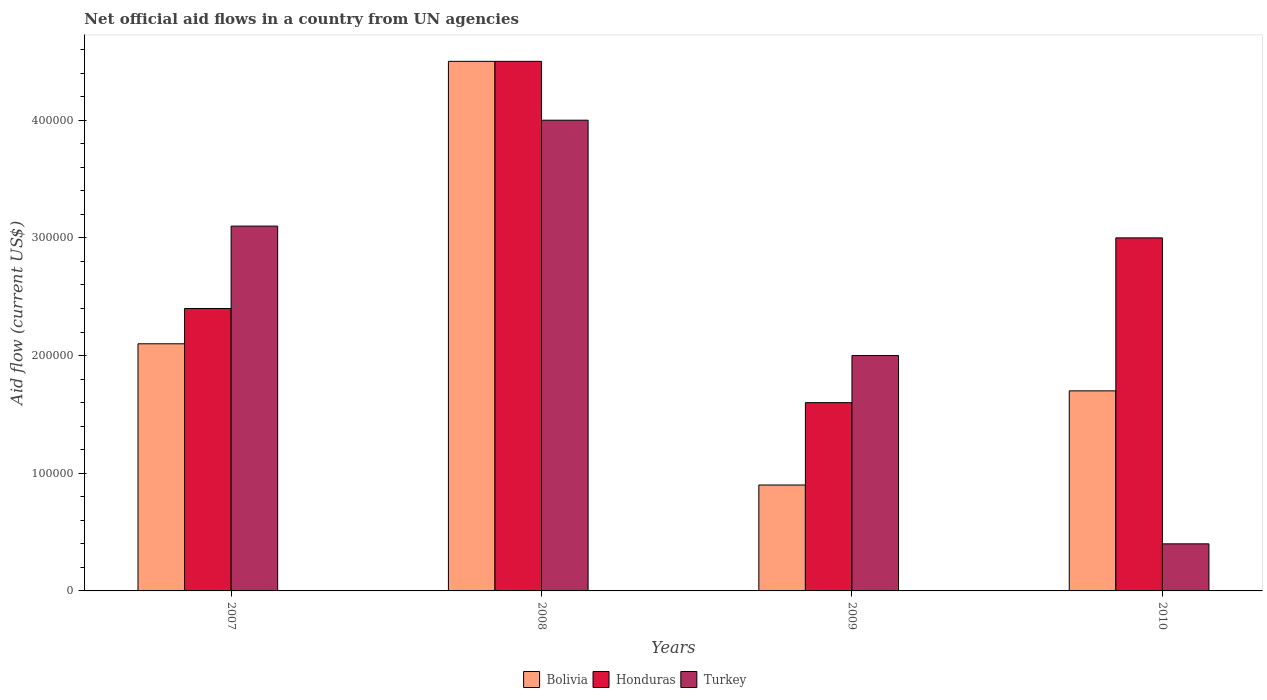How many different coloured bars are there?
Give a very brief answer. 3. How many groups of bars are there?
Offer a very short reply. 4. How many bars are there on the 4th tick from the right?
Provide a short and direct response. 3. What is the label of the 1st group of bars from the left?
Provide a short and direct response. 2007. Across all years, what is the maximum net official aid flow in Turkey?
Give a very brief answer. 4.00e+05. Across all years, what is the minimum net official aid flow in Turkey?
Your answer should be very brief. 4.00e+04. In which year was the net official aid flow in Honduras minimum?
Make the answer very short. 2009. What is the total net official aid flow in Bolivia in the graph?
Provide a short and direct response. 9.20e+05. What is the difference between the net official aid flow in Turkey in 2008 and that in 2009?
Your answer should be compact. 2.00e+05. What is the difference between the net official aid flow in Honduras in 2010 and the net official aid flow in Turkey in 2009?
Provide a short and direct response. 1.00e+05. What is the average net official aid flow in Honduras per year?
Provide a short and direct response. 2.88e+05. What is the ratio of the net official aid flow in Turkey in 2007 to that in 2008?
Offer a very short reply. 0.78. Is the net official aid flow in Turkey in 2007 less than that in 2009?
Your response must be concise. No. Is the difference between the net official aid flow in Honduras in 2008 and 2010 greater than the difference between the net official aid flow in Bolivia in 2008 and 2010?
Keep it short and to the point. No. What is the difference between the highest and the second highest net official aid flow in Turkey?
Your answer should be very brief. 9.00e+04. What is the difference between the highest and the lowest net official aid flow in Bolivia?
Your answer should be compact. 3.60e+05. What does the 2nd bar from the left in 2007 represents?
Offer a very short reply. Honduras. What does the 1st bar from the right in 2008 represents?
Your answer should be very brief. Turkey. How many bars are there?
Give a very brief answer. 12. Are all the bars in the graph horizontal?
Give a very brief answer. No. Does the graph contain any zero values?
Provide a short and direct response. No. Where does the legend appear in the graph?
Ensure brevity in your answer.  Bottom center. How are the legend labels stacked?
Offer a very short reply. Horizontal. What is the title of the graph?
Keep it short and to the point. Net official aid flows in a country from UN agencies. Does "Isle of Man" appear as one of the legend labels in the graph?
Offer a terse response. No. What is the label or title of the X-axis?
Offer a very short reply. Years. What is the Aid flow (current US$) in Turkey in 2007?
Give a very brief answer. 3.10e+05. What is the Aid flow (current US$) of Bolivia in 2008?
Your answer should be very brief. 4.50e+05. What is the Aid flow (current US$) in Turkey in 2008?
Your answer should be very brief. 4.00e+05. What is the Aid flow (current US$) in Bolivia in 2009?
Ensure brevity in your answer.  9.00e+04. What is the Aid flow (current US$) of Turkey in 2010?
Provide a short and direct response. 4.00e+04. Across all years, what is the maximum Aid flow (current US$) in Turkey?
Make the answer very short. 4.00e+05. Across all years, what is the minimum Aid flow (current US$) of Honduras?
Provide a succinct answer. 1.60e+05. Across all years, what is the minimum Aid flow (current US$) of Turkey?
Offer a very short reply. 4.00e+04. What is the total Aid flow (current US$) in Bolivia in the graph?
Make the answer very short. 9.20e+05. What is the total Aid flow (current US$) in Honduras in the graph?
Keep it short and to the point. 1.15e+06. What is the total Aid flow (current US$) in Turkey in the graph?
Make the answer very short. 9.50e+05. What is the difference between the Aid flow (current US$) in Turkey in 2007 and that in 2008?
Your response must be concise. -9.00e+04. What is the difference between the Aid flow (current US$) in Honduras in 2007 and that in 2009?
Your response must be concise. 8.00e+04. What is the difference between the Aid flow (current US$) in Turkey in 2007 and that in 2009?
Keep it short and to the point. 1.10e+05. What is the difference between the Aid flow (current US$) in Bolivia in 2007 and that in 2010?
Make the answer very short. 4.00e+04. What is the difference between the Aid flow (current US$) of Honduras in 2007 and that in 2010?
Your answer should be very brief. -6.00e+04. What is the difference between the Aid flow (current US$) of Turkey in 2007 and that in 2010?
Your response must be concise. 2.70e+05. What is the difference between the Aid flow (current US$) in Turkey in 2008 and that in 2010?
Make the answer very short. 3.60e+05. What is the difference between the Aid flow (current US$) in Honduras in 2009 and that in 2010?
Provide a short and direct response. -1.40e+05. What is the difference between the Aid flow (current US$) in Turkey in 2009 and that in 2010?
Provide a short and direct response. 1.60e+05. What is the difference between the Aid flow (current US$) in Bolivia in 2007 and the Aid flow (current US$) in Honduras in 2008?
Make the answer very short. -2.40e+05. What is the difference between the Aid flow (current US$) of Bolivia in 2007 and the Aid flow (current US$) of Turkey in 2009?
Your answer should be compact. 10000. What is the difference between the Aid flow (current US$) of Honduras in 2007 and the Aid flow (current US$) of Turkey in 2010?
Offer a terse response. 2.00e+05. What is the difference between the Aid flow (current US$) of Bolivia in 2008 and the Aid flow (current US$) of Honduras in 2009?
Your answer should be compact. 2.90e+05. What is the difference between the Aid flow (current US$) of Bolivia in 2008 and the Aid flow (current US$) of Turkey in 2009?
Your answer should be very brief. 2.50e+05. What is the difference between the Aid flow (current US$) of Bolivia in 2008 and the Aid flow (current US$) of Honduras in 2010?
Give a very brief answer. 1.50e+05. What is the difference between the Aid flow (current US$) in Honduras in 2009 and the Aid flow (current US$) in Turkey in 2010?
Your answer should be very brief. 1.20e+05. What is the average Aid flow (current US$) in Bolivia per year?
Keep it short and to the point. 2.30e+05. What is the average Aid flow (current US$) of Honduras per year?
Offer a terse response. 2.88e+05. What is the average Aid flow (current US$) in Turkey per year?
Keep it short and to the point. 2.38e+05. In the year 2007, what is the difference between the Aid flow (current US$) of Bolivia and Aid flow (current US$) of Honduras?
Provide a short and direct response. -3.00e+04. In the year 2007, what is the difference between the Aid flow (current US$) in Honduras and Aid flow (current US$) in Turkey?
Your answer should be very brief. -7.00e+04. In the year 2008, what is the difference between the Aid flow (current US$) in Bolivia and Aid flow (current US$) in Turkey?
Ensure brevity in your answer.  5.00e+04. In the year 2008, what is the difference between the Aid flow (current US$) in Honduras and Aid flow (current US$) in Turkey?
Ensure brevity in your answer.  5.00e+04. In the year 2010, what is the difference between the Aid flow (current US$) in Bolivia and Aid flow (current US$) in Turkey?
Provide a short and direct response. 1.30e+05. In the year 2010, what is the difference between the Aid flow (current US$) in Honduras and Aid flow (current US$) in Turkey?
Your response must be concise. 2.60e+05. What is the ratio of the Aid flow (current US$) in Bolivia in 2007 to that in 2008?
Provide a short and direct response. 0.47. What is the ratio of the Aid flow (current US$) of Honduras in 2007 to that in 2008?
Keep it short and to the point. 0.53. What is the ratio of the Aid flow (current US$) in Turkey in 2007 to that in 2008?
Ensure brevity in your answer.  0.78. What is the ratio of the Aid flow (current US$) in Bolivia in 2007 to that in 2009?
Ensure brevity in your answer.  2.33. What is the ratio of the Aid flow (current US$) in Turkey in 2007 to that in 2009?
Give a very brief answer. 1.55. What is the ratio of the Aid flow (current US$) of Bolivia in 2007 to that in 2010?
Ensure brevity in your answer.  1.24. What is the ratio of the Aid flow (current US$) of Honduras in 2007 to that in 2010?
Offer a very short reply. 0.8. What is the ratio of the Aid flow (current US$) of Turkey in 2007 to that in 2010?
Your answer should be very brief. 7.75. What is the ratio of the Aid flow (current US$) in Bolivia in 2008 to that in 2009?
Give a very brief answer. 5. What is the ratio of the Aid flow (current US$) in Honduras in 2008 to that in 2009?
Your answer should be compact. 2.81. What is the ratio of the Aid flow (current US$) in Turkey in 2008 to that in 2009?
Keep it short and to the point. 2. What is the ratio of the Aid flow (current US$) in Bolivia in 2008 to that in 2010?
Make the answer very short. 2.65. What is the ratio of the Aid flow (current US$) in Honduras in 2008 to that in 2010?
Provide a succinct answer. 1.5. What is the ratio of the Aid flow (current US$) in Bolivia in 2009 to that in 2010?
Ensure brevity in your answer.  0.53. What is the ratio of the Aid flow (current US$) of Honduras in 2009 to that in 2010?
Provide a succinct answer. 0.53. What is the difference between the highest and the second highest Aid flow (current US$) of Bolivia?
Your response must be concise. 2.40e+05. What is the difference between the highest and the second highest Aid flow (current US$) of Turkey?
Ensure brevity in your answer.  9.00e+04. What is the difference between the highest and the lowest Aid flow (current US$) of Turkey?
Your answer should be very brief. 3.60e+05. 